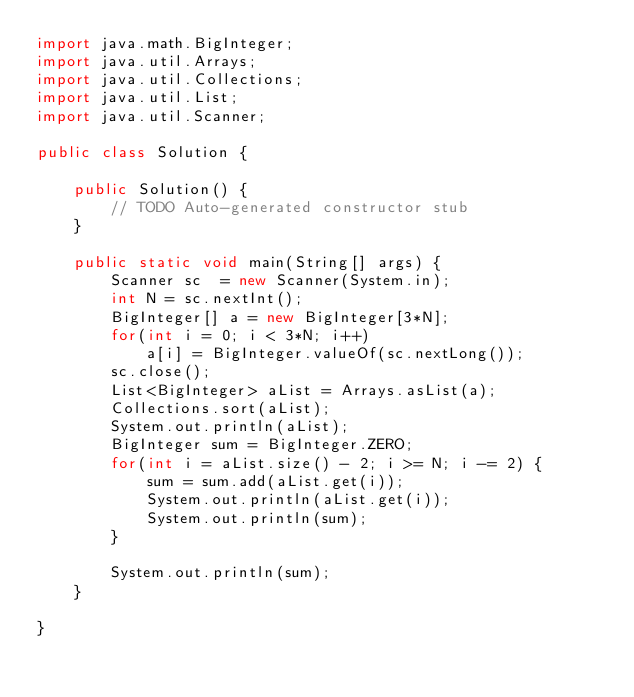Convert code to text. <code><loc_0><loc_0><loc_500><loc_500><_Java_>import java.math.BigInteger;
import java.util.Arrays;
import java.util.Collections;
import java.util.List;
import java.util.Scanner;

public class Solution {

	public Solution() {
		// TODO Auto-generated constructor stub
	}

	public static void main(String[] args) {
		Scanner sc  = new Scanner(System.in);
		int N = sc.nextInt();
		BigInteger[] a = new BigInteger[3*N];
		for(int i = 0; i < 3*N; i++)
			a[i] = BigInteger.valueOf(sc.nextLong());
		sc.close();
		List<BigInteger> aList = Arrays.asList(a);
		Collections.sort(aList);
		System.out.println(aList);
		BigInteger sum = BigInteger.ZERO;
		for(int i = aList.size() - 2; i >= N; i -= 2) {
			sum = sum.add(aList.get(i));
			System.out.println(aList.get(i));
			System.out.println(sum);
		}
		
		System.out.println(sum);
	}

}
</code> 